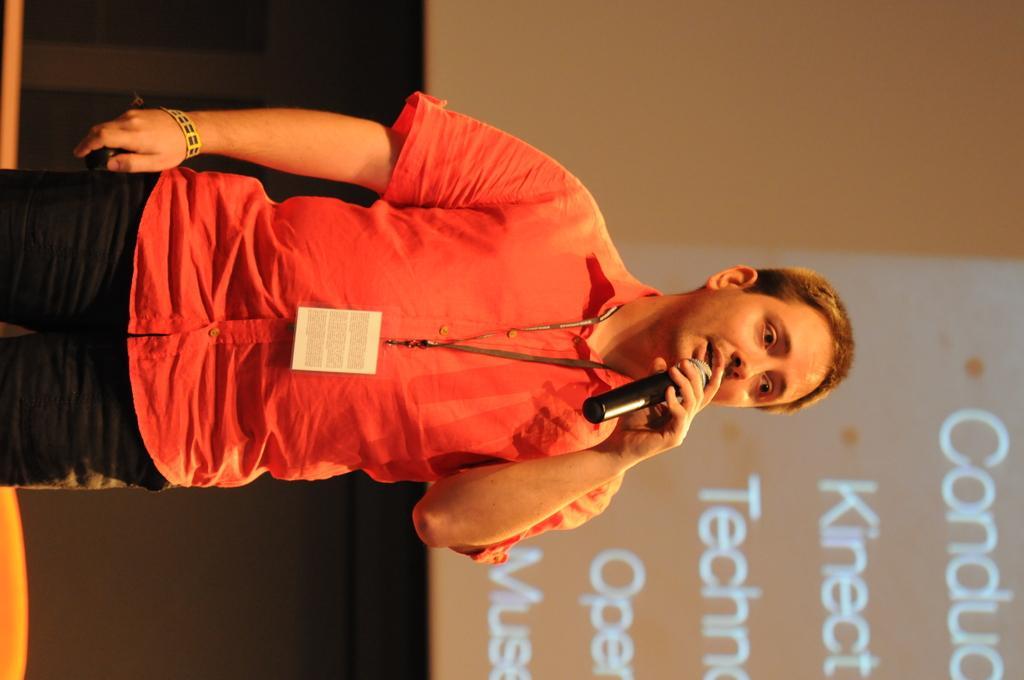Could you give a brief overview of what you see in this image? In this image I can see a person ,holding a mike ,on the right side I can see a screen. 